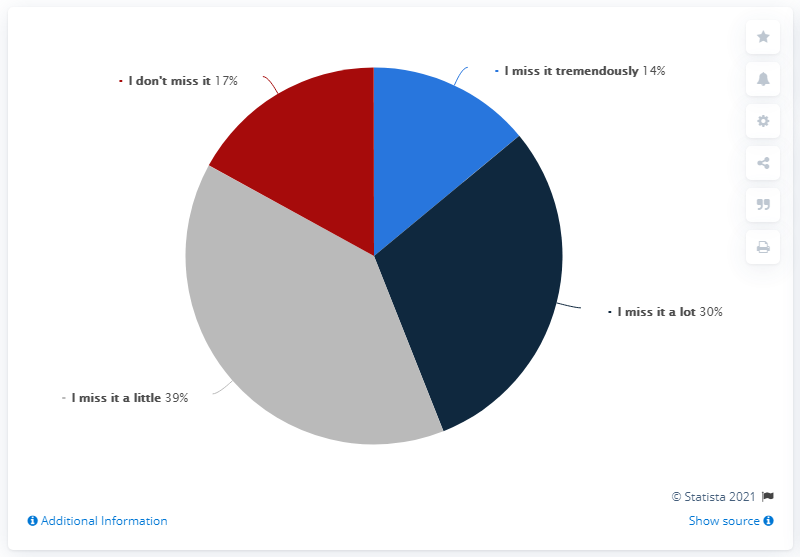Outline some significant characteristics in this image. The value of 'I miss it a lot' being more than 'I miss it a little' is not the case. The color of the pie segment labeled "I miss it a little" is gray. 